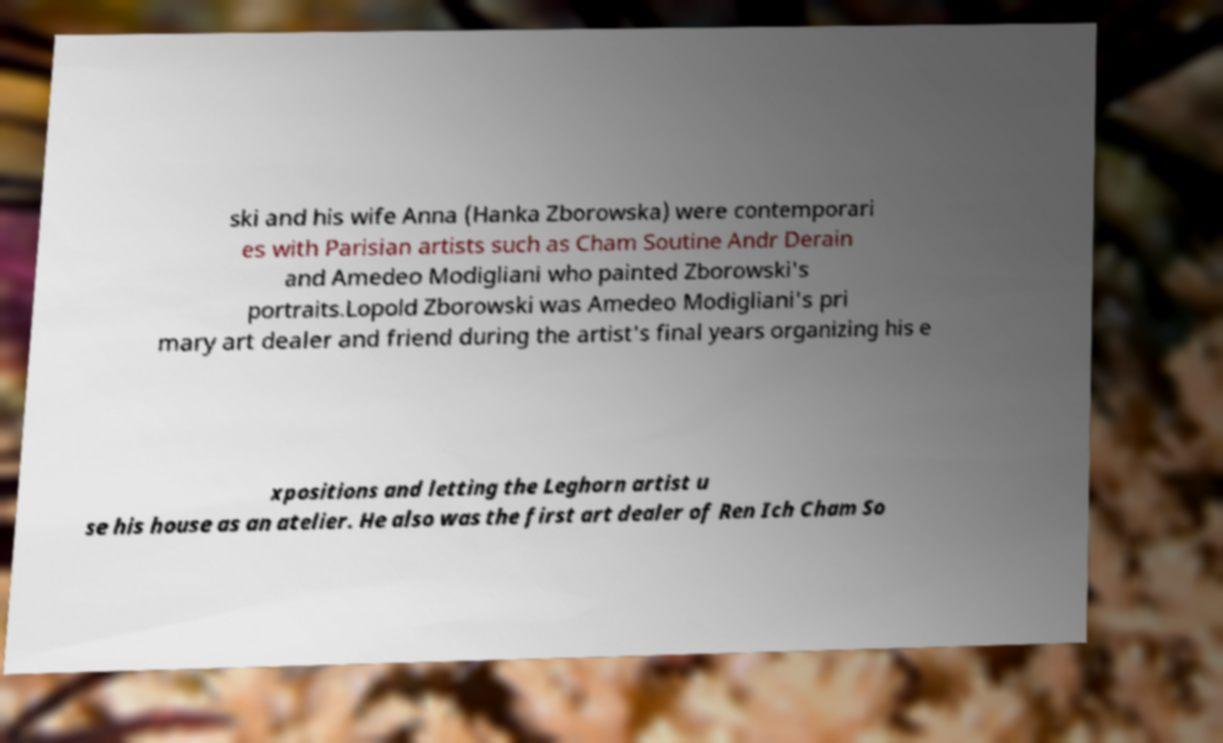What messages or text are displayed in this image? I need them in a readable, typed format. ski and his wife Anna (Hanka Zborowska) were contemporari es with Parisian artists such as Cham Soutine Andr Derain and Amedeo Modigliani who painted Zborowski's portraits.Lopold Zborowski was Amedeo Modigliani's pri mary art dealer and friend during the artist's final years organizing his e xpositions and letting the Leghorn artist u se his house as an atelier. He also was the first art dealer of Ren Ich Cham So 